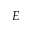Convert formula to latex. <formula><loc_0><loc_0><loc_500><loc_500>E</formula> 